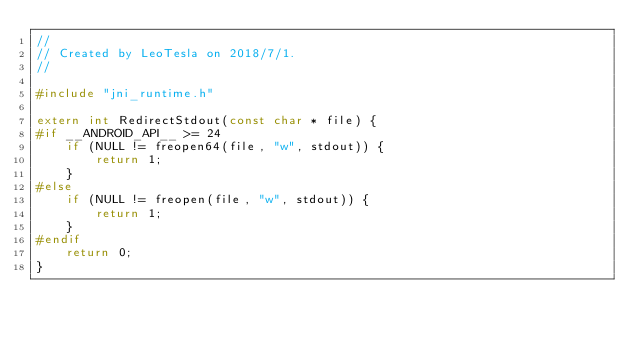<code> <loc_0><loc_0><loc_500><loc_500><_C_>//
// Created by LeoTesla on 2018/7/1.
//

#include "jni_runtime.h"

extern int RedirectStdout(const char * file) {
#if __ANDROID_API__ >= 24
    if (NULL != freopen64(file, "w", stdout)) {
        return 1;
    }
#else
    if (NULL != freopen(file, "w", stdout)) {
        return 1;
    }
#endif
    return 0;
}</code> 